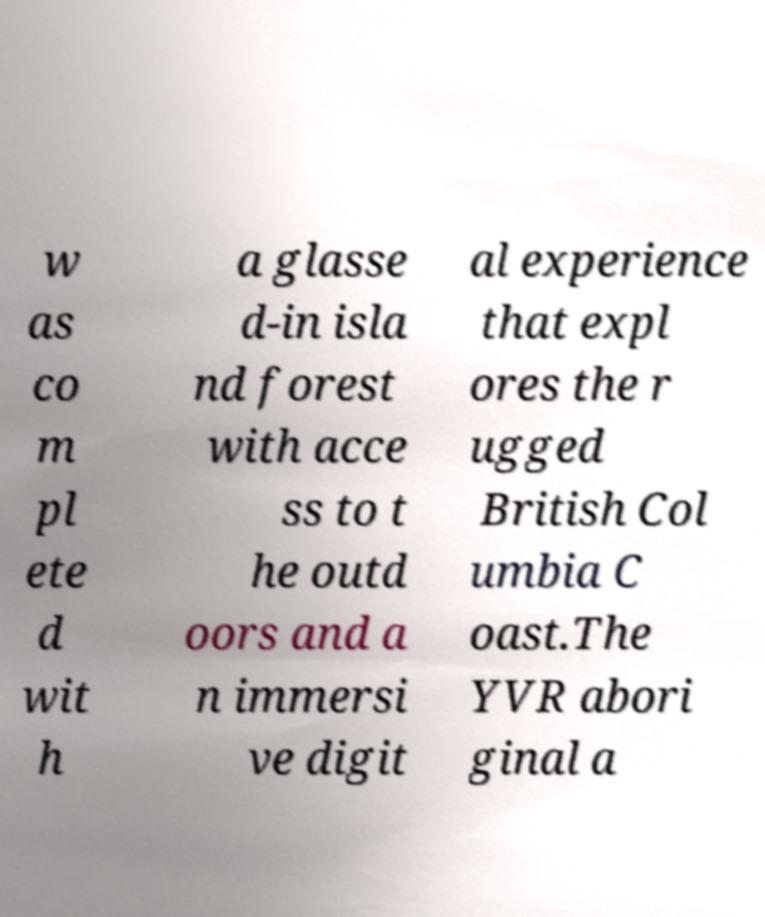Please read and relay the text visible in this image. What does it say? w as co m pl ete d wit h a glasse d-in isla nd forest with acce ss to t he outd oors and a n immersi ve digit al experience that expl ores the r ugged British Col umbia C oast.The YVR abori ginal a 